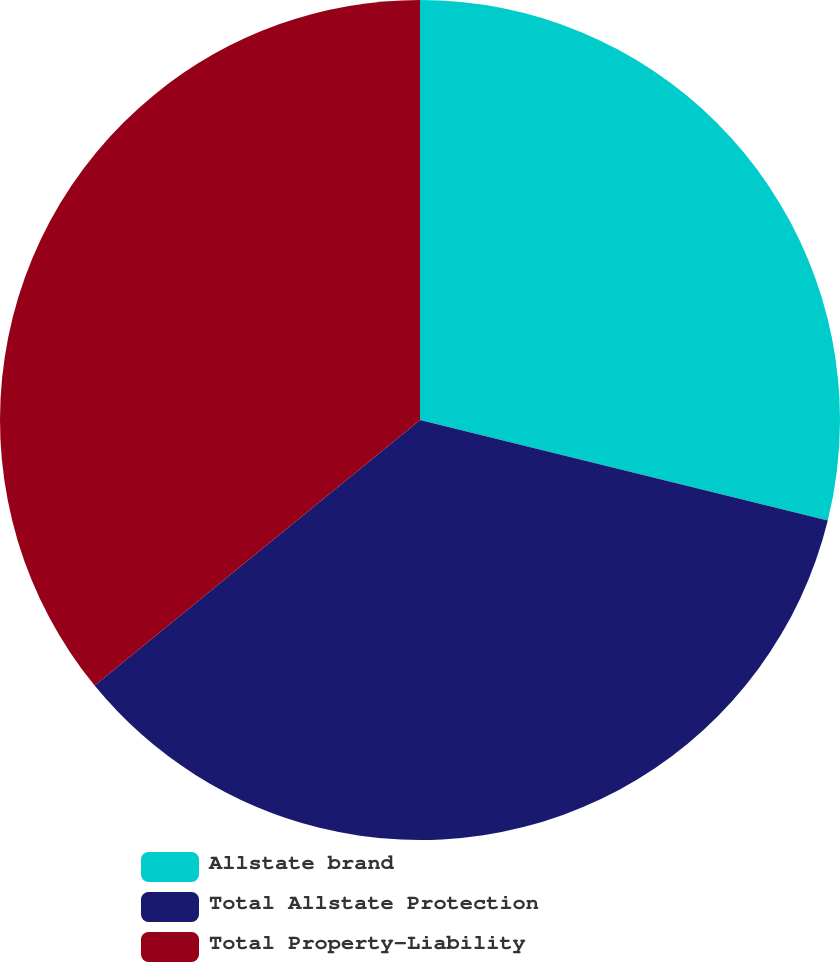Convert chart to OTSL. <chart><loc_0><loc_0><loc_500><loc_500><pie_chart><fcel>Allstate brand<fcel>Total Allstate Protection<fcel>Total Property-Liability<nl><fcel>28.85%<fcel>35.26%<fcel>35.9%<nl></chart> 